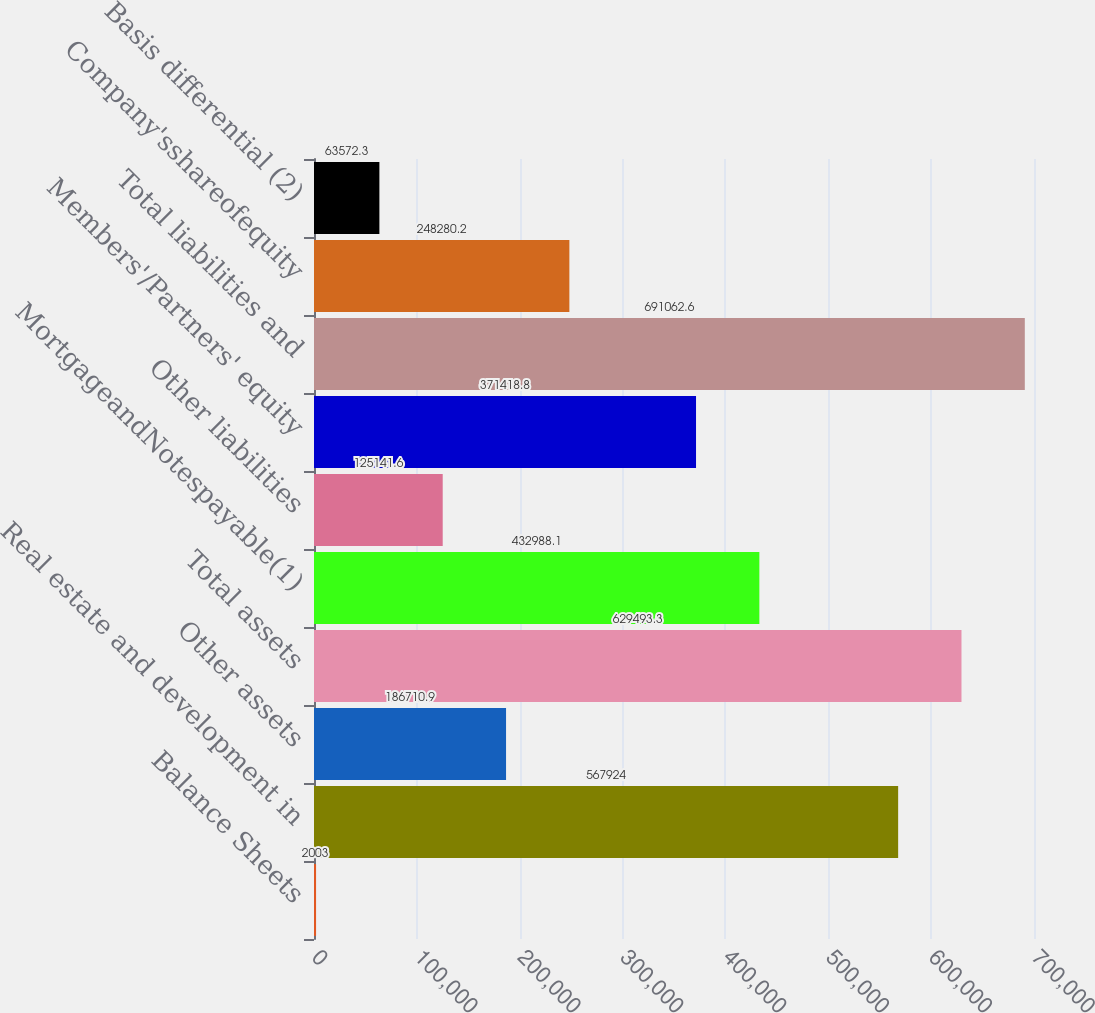<chart> <loc_0><loc_0><loc_500><loc_500><bar_chart><fcel>Balance Sheets<fcel>Real estate and development in<fcel>Other assets<fcel>Total assets<fcel>MortgageandNotespayable(1)<fcel>Other liabilities<fcel>Members'/Partners' equity<fcel>Total liabilities and<fcel>Company'sshareofequity<fcel>Basis differential (2)<nl><fcel>2003<fcel>567924<fcel>186711<fcel>629493<fcel>432988<fcel>125142<fcel>371419<fcel>691063<fcel>248280<fcel>63572.3<nl></chart> 